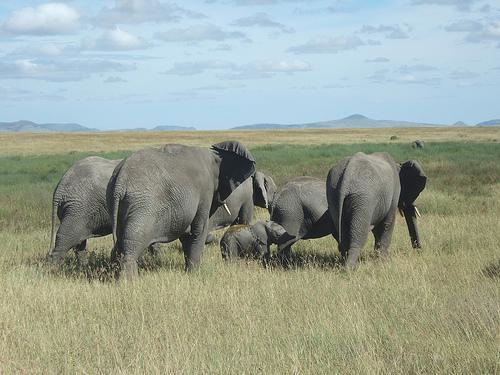How many tusks does the elephant on the right have?
Give a very brief answer. 2. How many baby elephants are pictured?
Give a very brief answer. 1. 